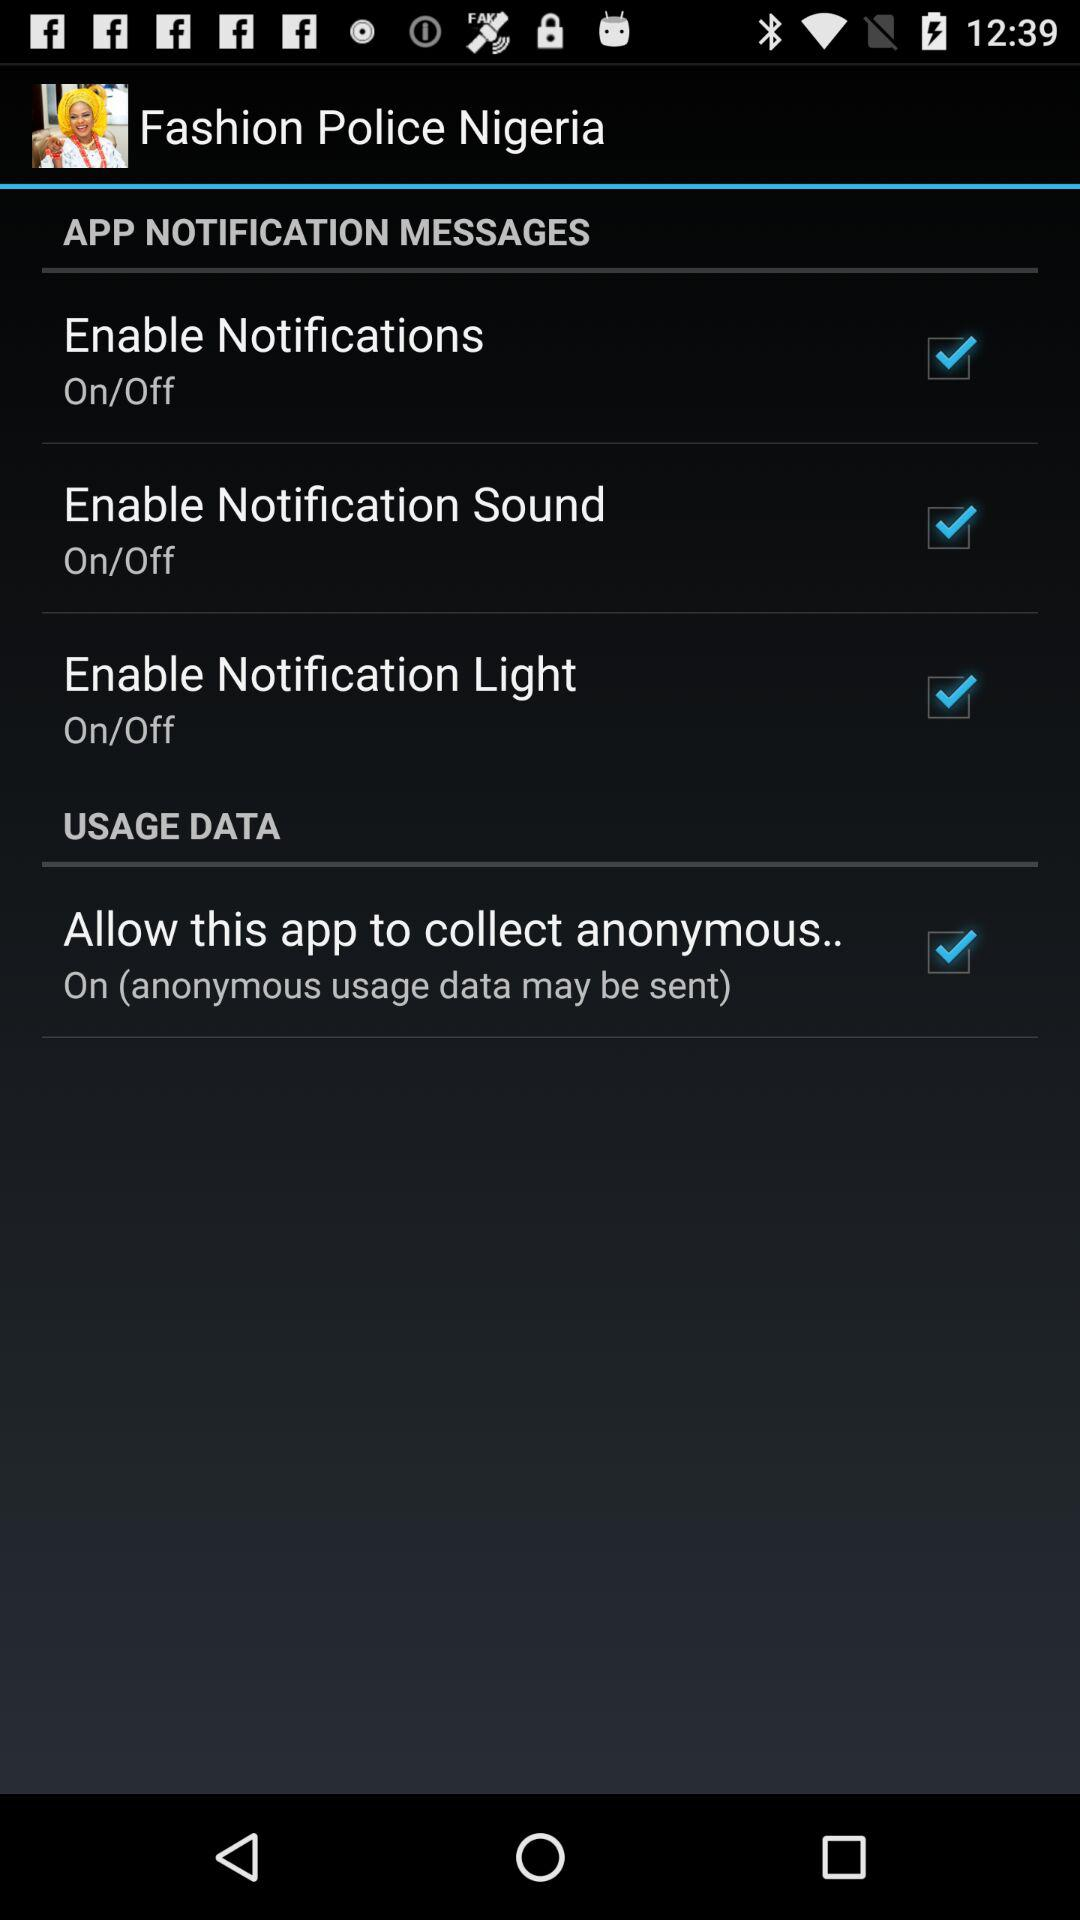What is the current status of the "Enable Notification Light"? The current status of the "Enable Notification Light" is "on". 